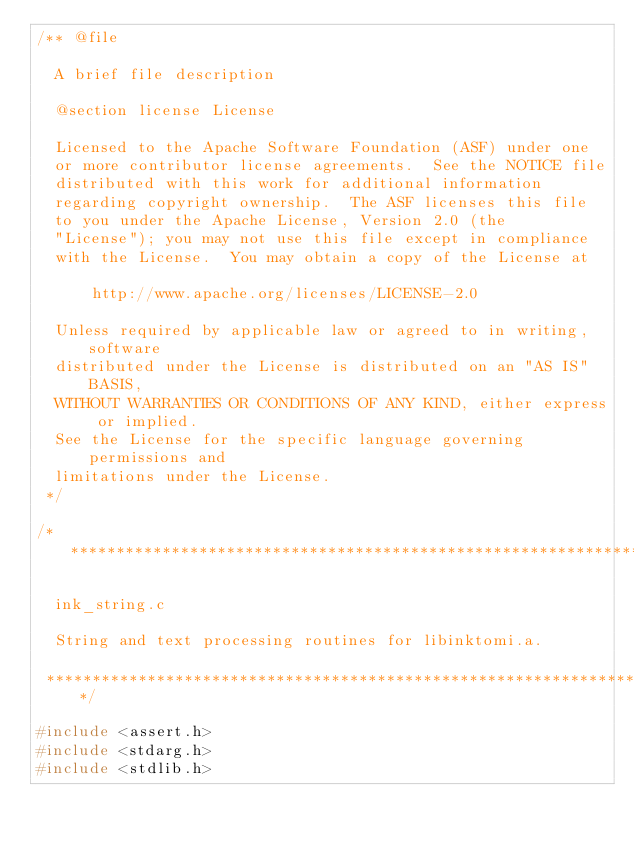Convert code to text. <code><loc_0><loc_0><loc_500><loc_500><_C++_>/** @file

  A brief file description

  @section license License

  Licensed to the Apache Software Foundation (ASF) under one
  or more contributor license agreements.  See the NOTICE file
  distributed with this work for additional information
  regarding copyright ownership.  The ASF licenses this file
  to you under the Apache License, Version 2.0 (the
  "License"); you may not use this file except in compliance
  with the License.  You may obtain a copy of the License at

      http://www.apache.org/licenses/LICENSE-2.0

  Unless required by applicable law or agreed to in writing, software
  distributed under the License is distributed on an "AS IS" BASIS,
  WITHOUT WARRANTIES OR CONDITIONS OF ANY KIND, either express or implied.
  See the License for the specific language governing permissions and
  limitations under the License.
 */

/****************************************************************************
 
  ink_string.c
 
  String and text processing routines for libinktomi.a.
 
 ****************************************************************************/

#include <assert.h>
#include <stdarg.h>
#include <stdlib.h></code> 